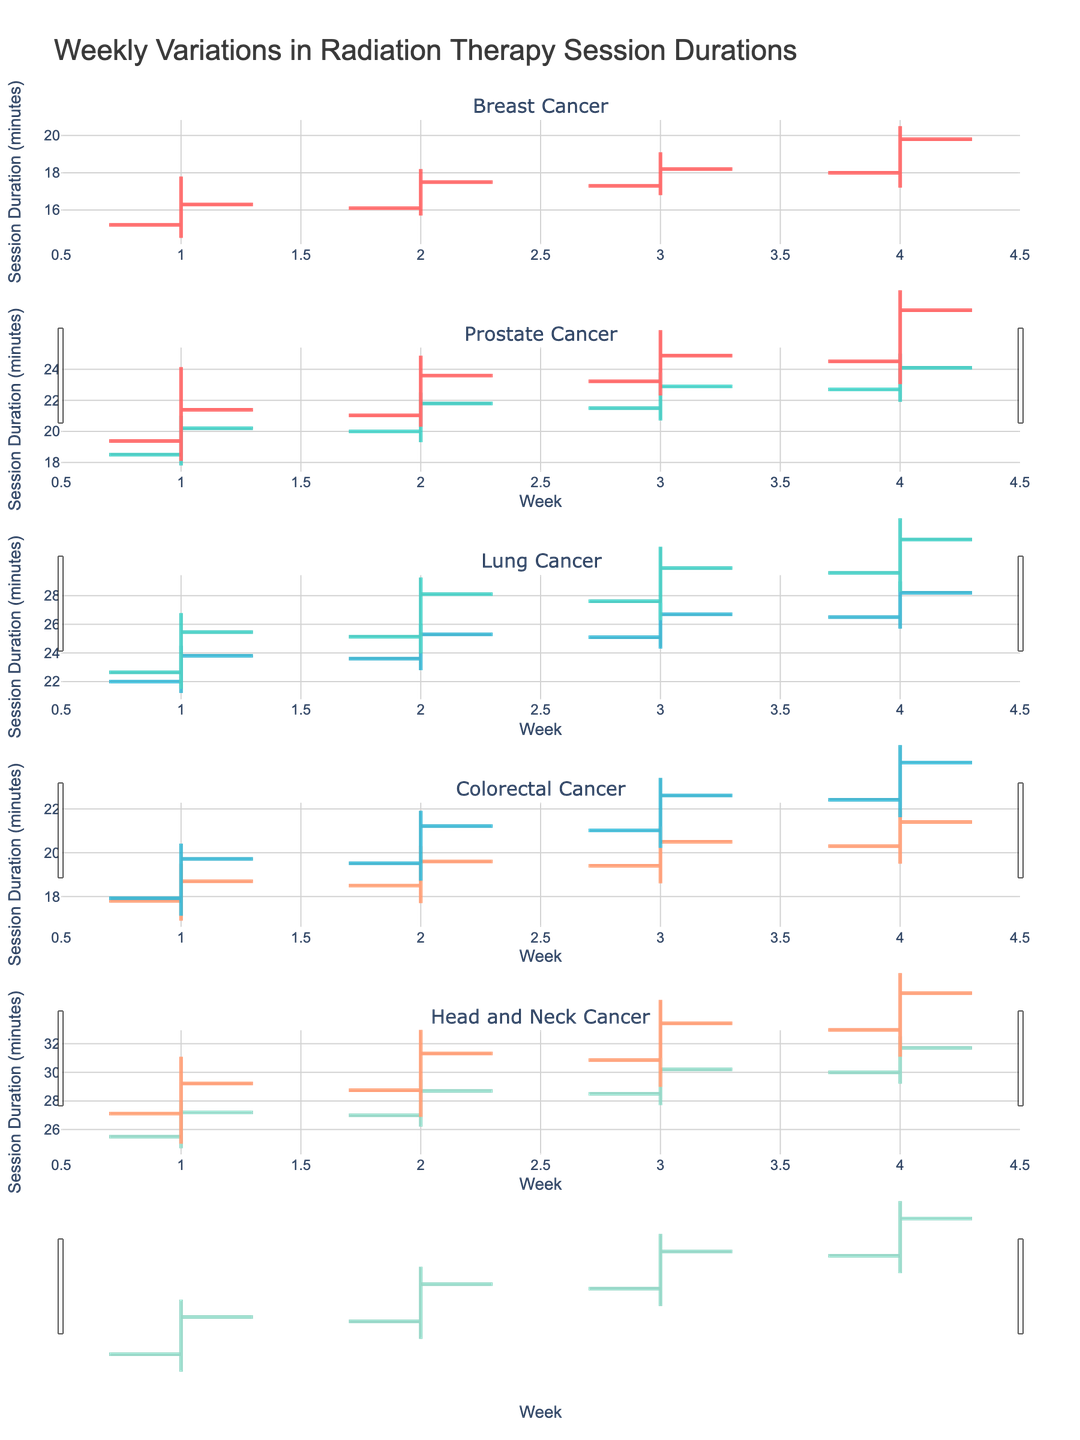What is the title of the figure? The title of the figure is displayed prominently at the top and reads 'Weekly Variations in Radiation Therapy Session Durations'.
Answer: Weekly Variations in Radiation Therapy Session Durations Which cancer type displays the highest session duration within the 4-week period? By inspecting the highest value (High) for each cancer type over the 4-week period, Head and Neck Cancer has the highest session duration with a value of 32.5 minutes in Week 4.
Answer: Head and Neck Cancer What is the average closing session duration for Breast Cancer over the 4-week period? The closing values for Breast Cancer over the 4 weeks are 16.3, 17.5, 18.2, and 19.8. Adding them gives 71.8. Dividing by 4, the average is 71.8 / 4 = 17.95 minutes.
Answer: 17.95 minutes Which week had the least variation in session duration for Colorectal Cancer? To determine the week with the least variation, calculate the range (High - Low) for each week of Colorectal Cancer. The ranges are Week 1: 2.6, Week 2: 2.6, Week 3: 2.6, and Week 4: 2.5. Week 4 has the smallest variation.
Answer: Week 4 Compare the opening and closing session durations for Lung Cancer in Week 3. Was there an increase or decrease? For Week 3 of Lung Cancer, the opening session duration is 25.1 minutes and the closing session duration is 26.7 minutes. Observing the difference (26.7 - 25.1), there was an increase of 1.6 minutes.
Answer: Increase Which cancer type has the lowest opening session duration in Week 1? By comparing the opening values for each cancer type in Week 1, Breast Cancer has the lowest opening session duration with a value of 15.2 minutes.
Answer: Breast Cancer What is the overall trend in session duration for Prostate Cancer from Week 1 to Week 4? Observing the closing session durations for Prostate Cancer from Week 1 to Week 4 (20.2 to 24.1), there is a clear increasing trend in the session durations over time.
Answer: Increasing trend How is the variation for Head and Neck Cancer in Week 2 compared to Week 1? To compare the variation, calculate the range (High - Low) for Head and Neck Cancer in Week 1 (28.0 - 24.7 = 3.3) and Week 2 (29.5 - 26.2 = 3.3). The variations are equal for both weeks at 3.3 minutes.
Answer: Equal What was the largest increase in closing values (in minutes) from one week to the next for any cancer type? To find the largest increase, compare the week-to-week closing values for all cancer types. The largest increase is for Head and Neck Cancer from Week 3 (30.2) to Week 4 (31.7), with an increase of 1.5 minutes.
Answer: 1.5 minutes 